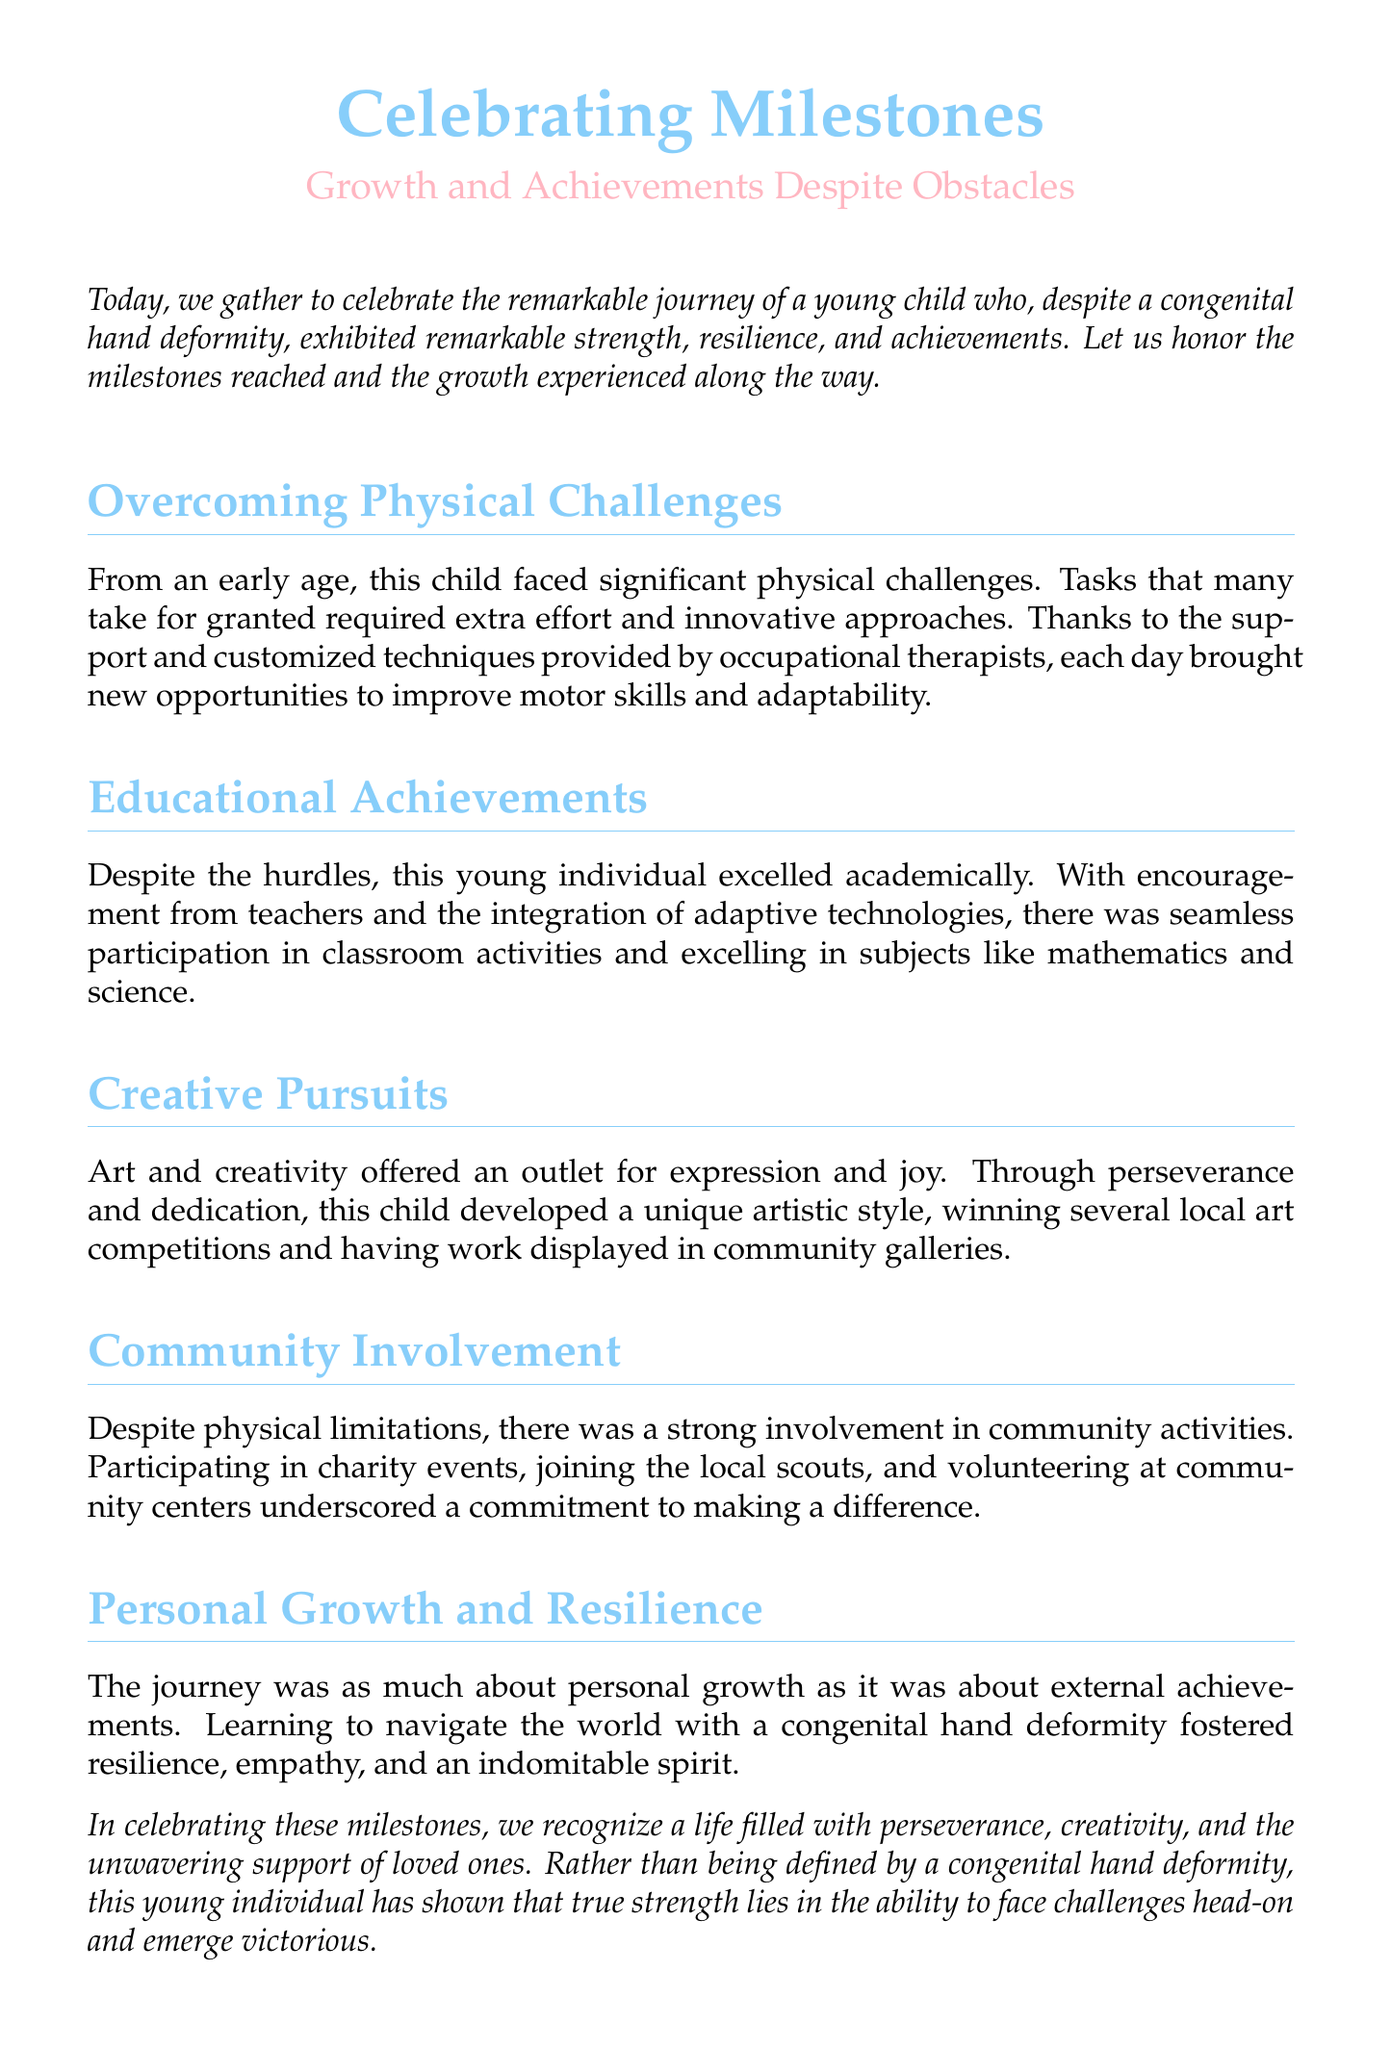What is being celebrated in the document? The document celebrates milestones and growth achievements despite obstacles faced by a young child.
Answer: Milestones What type of challenges did the child face? The challenges mentioned are physical challenges due to a congenital hand deformity.
Answer: Physical challenges Who provided support to improve motor skills? The document states that occupational therapists provided support and customized techniques.
Answer: Occupational therapists In which subjects did the child excel academically? The child excelled in subjects such as mathematics and science.
Answer: Mathematics and science What creative pursuit is highlighted in the document? Art and creativity are mentioned as significant outlets for expression and joy.
Answer: Art What did the child win in community competitions? The child won several local art competitions.
Answer: Local art competitions What qualities did the journey foster in the child? The journey fostered resilience, empathy, and an indomitable spirit.
Answer: Resilience, empathy, and indomitable spirit What type of events did the child participate in within the community? The child participated in charity events, joined local scouts, and volunteered.
Answer: Charity events What is the main theme of the eulogy? The eulogy focuses on celebrating the perseverance and achievements of the child.
Answer: Perseverance and achievements 